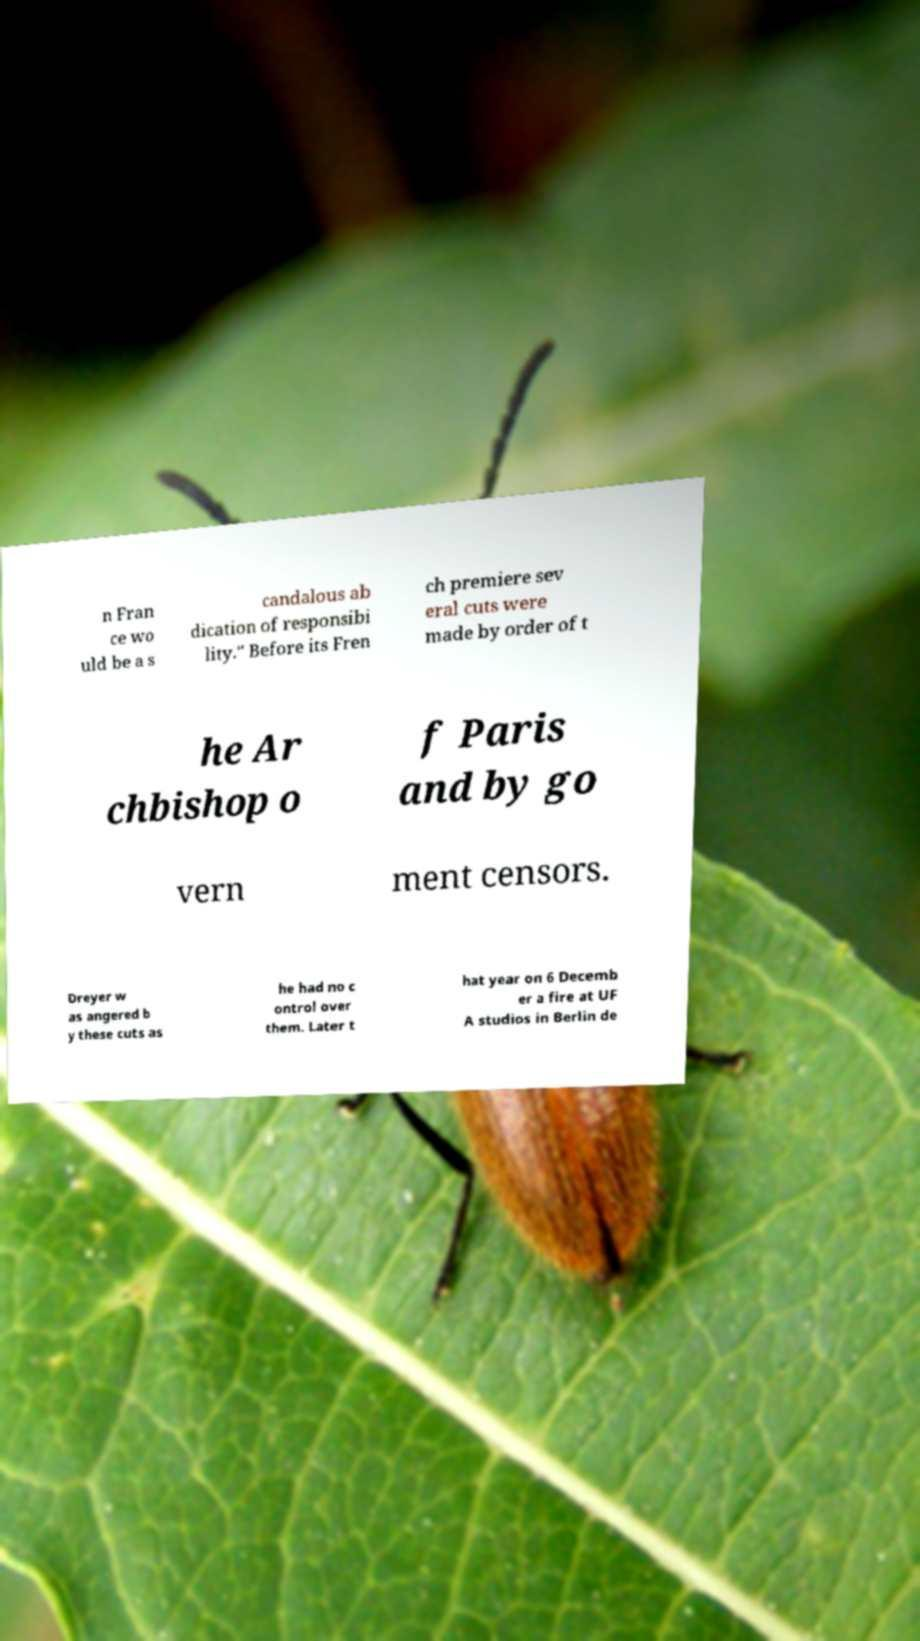Please identify and transcribe the text found in this image. n Fran ce wo uld be a s candalous ab dication of responsibi lity." Before its Fren ch premiere sev eral cuts were made by order of t he Ar chbishop o f Paris and by go vern ment censors. Dreyer w as angered b y these cuts as he had no c ontrol over them. Later t hat year on 6 Decemb er a fire at UF A studios in Berlin de 